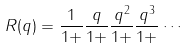<formula> <loc_0><loc_0><loc_500><loc_500>R ( q ) = \frac { 1 } { 1 + } \frac { q } { 1 + } \frac { q ^ { 2 } } { 1 + } \frac { q ^ { 3 } } { 1 + } \cdots</formula> 